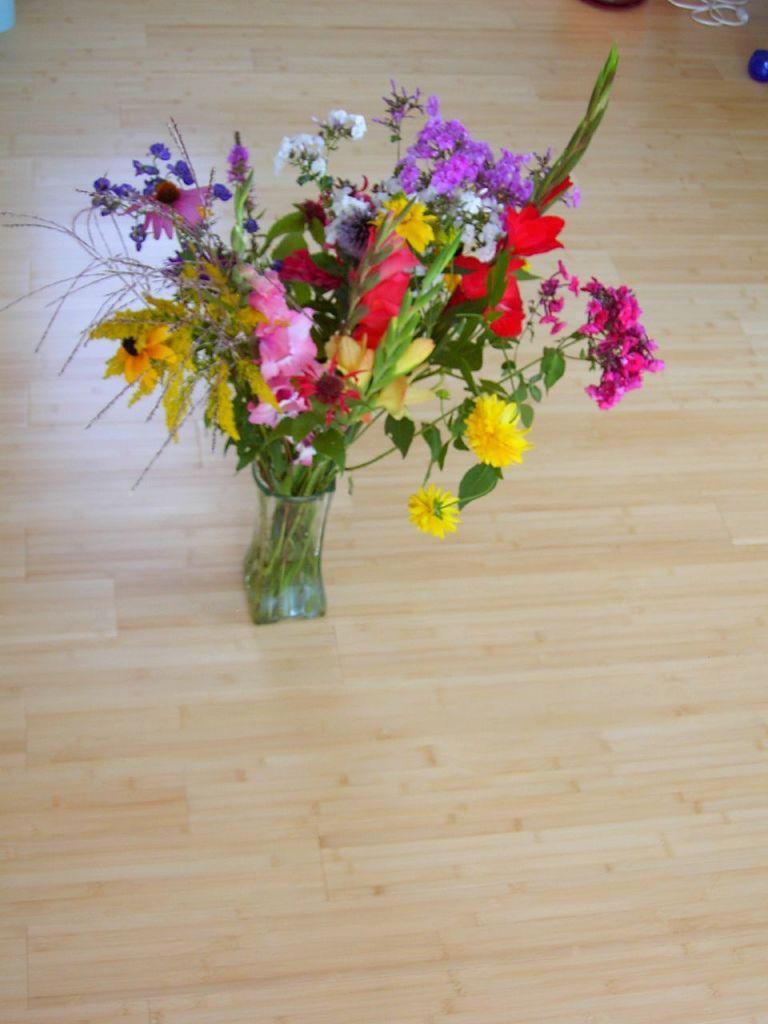In one or two sentences, can you explain what this image depicts? In this picture we can see a flower vase on the wooden floor and behind the flower vase there are some objects. 